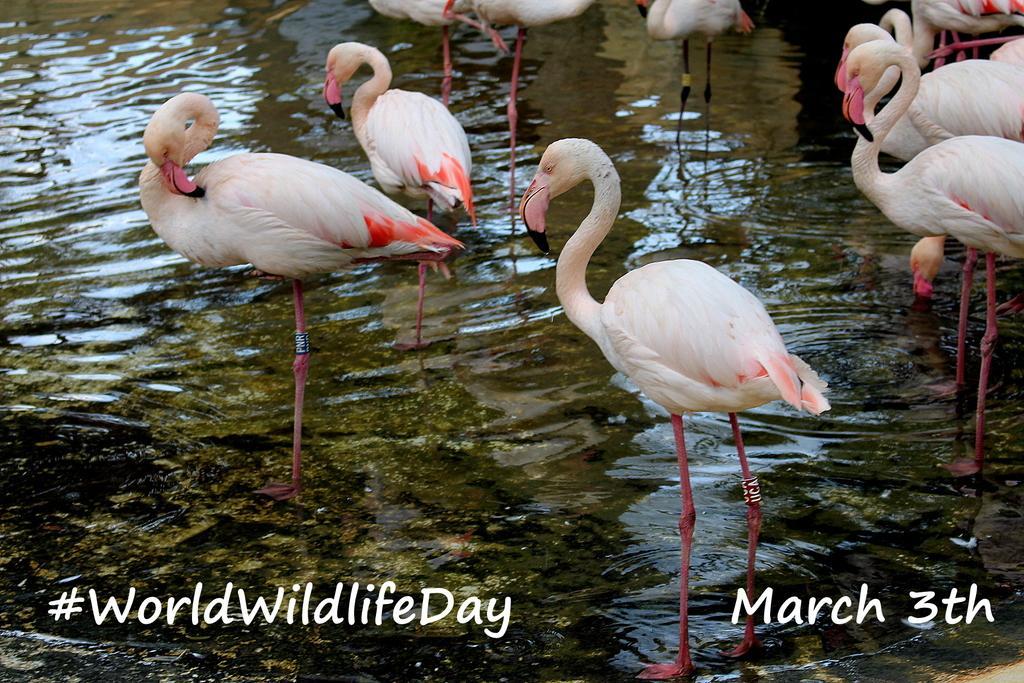How would you summarize this image in a sentence or two? In this picture we can see some flamingo birds standing here, at the bottom there is water, we can see some text here. 